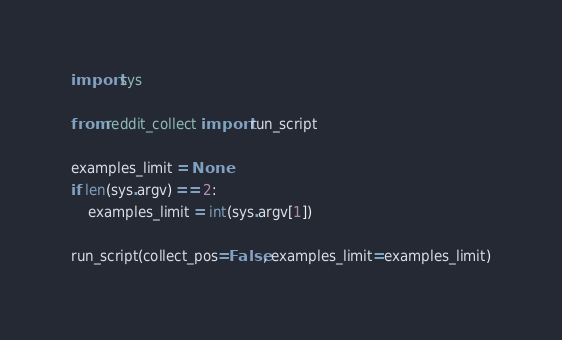<code> <loc_0><loc_0><loc_500><loc_500><_Python_>import sys

from reddit_collect import run_script

examples_limit = None
if len(sys.argv) == 2:
	examples_limit = int(sys.argv[1])

run_script(collect_pos=False, examples_limit=examples_limit)</code> 